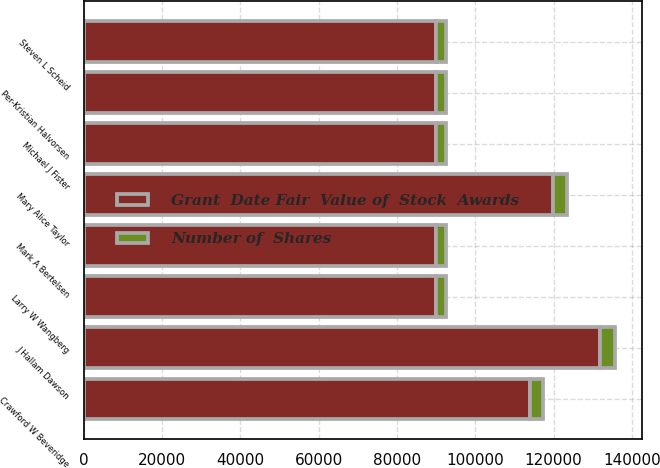Convert chart to OTSL. <chart><loc_0><loc_0><loc_500><loc_500><stacked_bar_chart><ecel><fcel>J Hallam Dawson<fcel>Mary Alice Taylor<fcel>Crawford W Beveridge<fcel>Mark A Bertelsen<fcel>Michael J Fister<fcel>Per-Kristian Halvorsen<fcel>Steven L Scheid<fcel>Larry W Wangberg<nl><fcel>Number of  Shares<fcel>3837<fcel>3488<fcel>3314<fcel>2616<fcel>2616<fcel>2616<fcel>2616<fcel>2616<nl><fcel>Grant  Date Fair  Value of  Stock  Awards<fcel>131954<fcel>119952<fcel>113968<fcel>89964<fcel>89964<fcel>89964<fcel>89964<fcel>89964<nl></chart> 